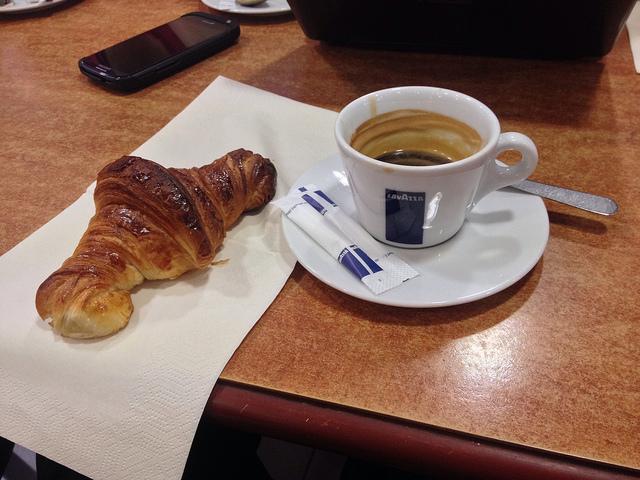What kind of pastry is this?
Keep it brief. Croissant. How many place settings are visible?
Concise answer only. 1. How many sugar packets are on the plate?
Concise answer only. 2. Is there any coffee left in the cup?
Quick response, please. Yes. What color is the saucer?
Concise answer only. White. Is the cup full?
Give a very brief answer. No. Is this a dessert?
Quick response, please. Yes. What is that food?
Quick response, please. Croissant. Where is the phone?
Concise answer only. On table. What color are the glasses?
Answer briefly. White. What does the writing say on the cup?
Keep it brief. Lavinia. Where is the creamer?
Give a very brief answer. On saucer. 